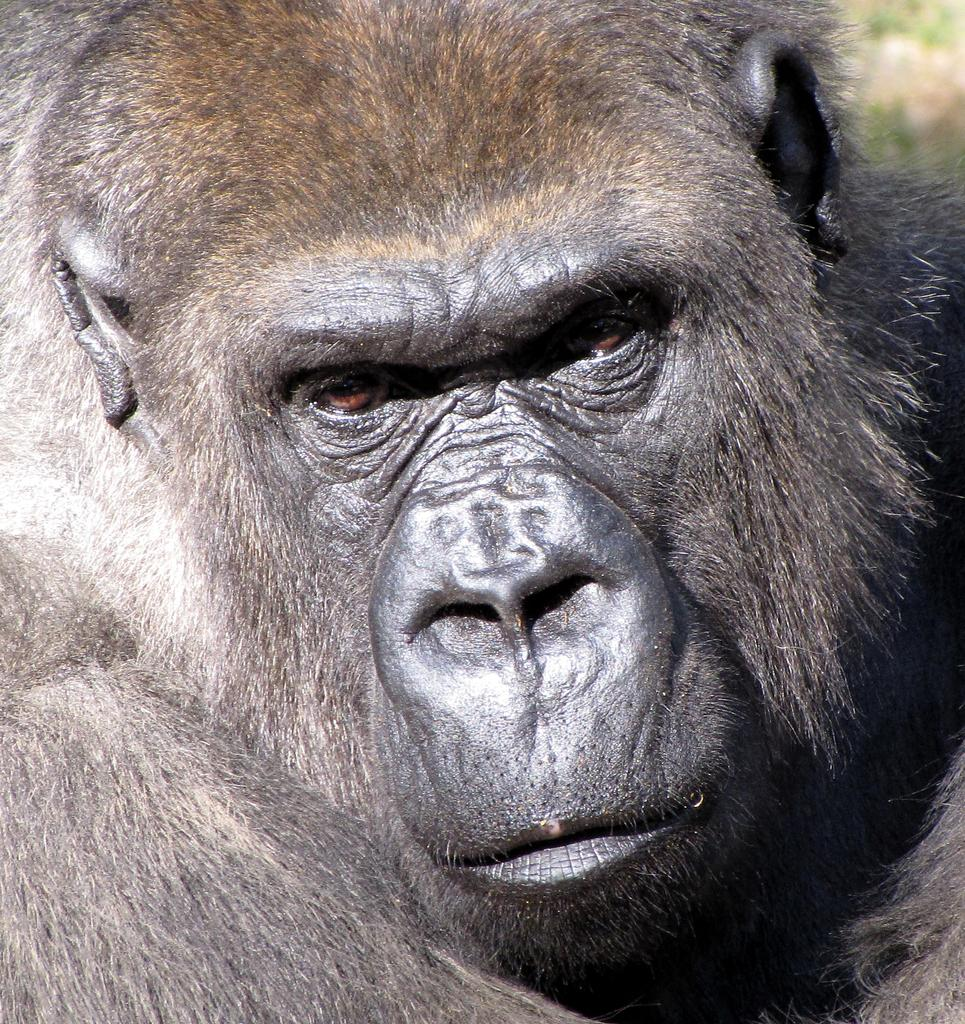What is the main subject of the image? There is a gorilla's face in the image. Can you describe the background of the image? The background is blurred. What type of beetle can be seen crawling on the gorilla's face in the image? There is no beetle present on the gorilla's face in the image. What impulse might the gorilla be experiencing in the image? We cannot determine the gorilla's emotions or impulses from the image, as it only shows the gorilla's face. 